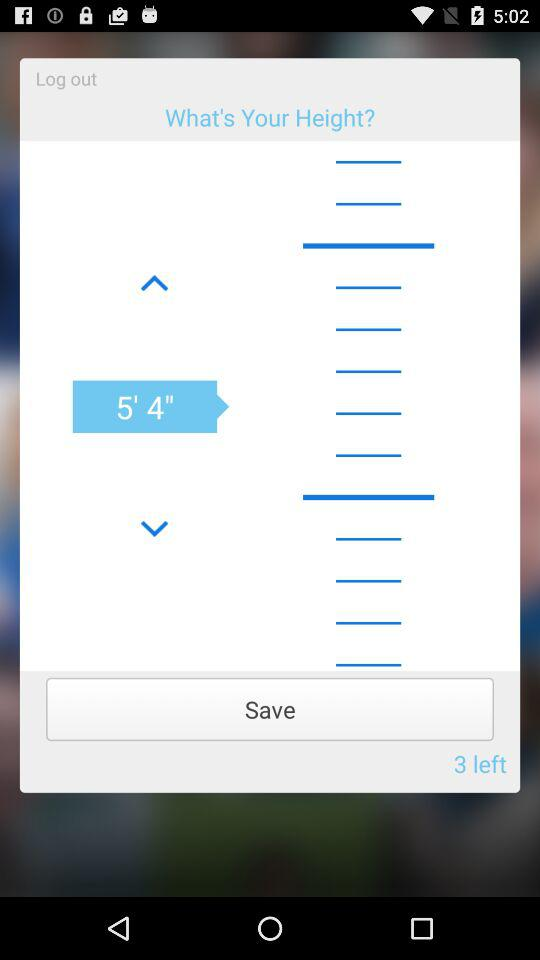What is the selected height? The selected height is 5' 4". 